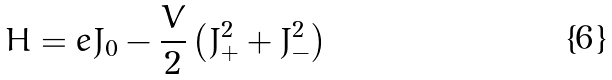Convert formula to latex. <formula><loc_0><loc_0><loc_500><loc_500>H = e J _ { 0 } - \frac { V } { 2 } \left ( J ^ { 2 } _ { + } + J ^ { 2 } _ { - } \right )</formula> 